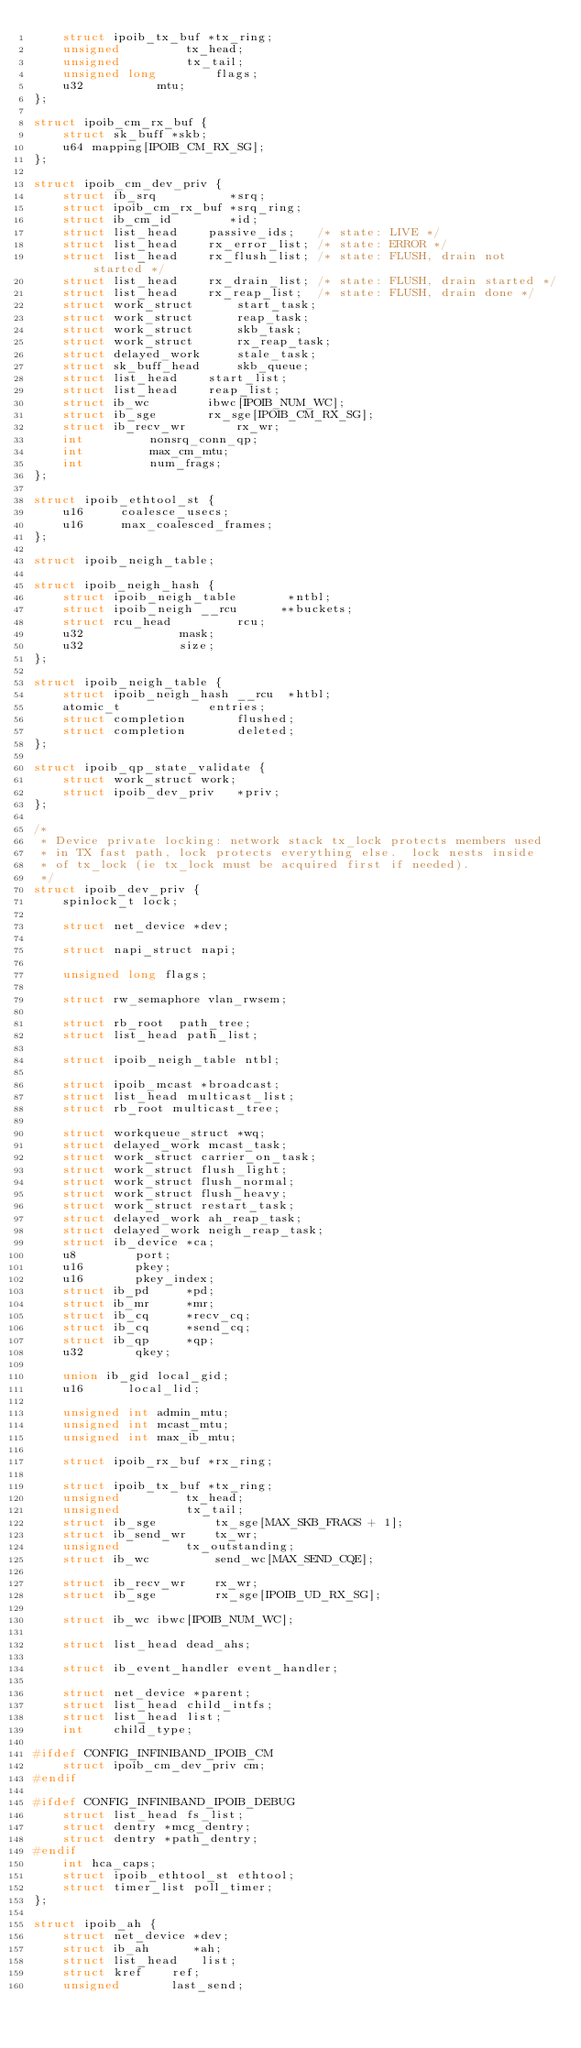<code> <loc_0><loc_0><loc_500><loc_500><_C_>	struct ipoib_tx_buf *tx_ring;
	unsigned	     tx_head;
	unsigned	     tx_tail;
	unsigned long	     flags;
	u32		     mtu;
};

struct ipoib_cm_rx_buf {
	struct sk_buff *skb;
	u64 mapping[IPOIB_CM_RX_SG];
};

struct ipoib_cm_dev_priv {
	struct ib_srq	       *srq;
	struct ipoib_cm_rx_buf *srq_ring;
	struct ib_cm_id	       *id;
	struct list_head	passive_ids;   /* state: LIVE */
	struct list_head	rx_error_list; /* state: ERROR */
	struct list_head	rx_flush_list; /* state: FLUSH, drain not started */
	struct list_head	rx_drain_list; /* state: FLUSH, drain started */
	struct list_head	rx_reap_list;  /* state: FLUSH, drain done */
	struct work_struct      start_task;
	struct work_struct      reap_task;
	struct work_struct      skb_task;
	struct work_struct      rx_reap_task;
	struct delayed_work     stale_task;
	struct sk_buff_head     skb_queue;
	struct list_head	start_list;
	struct list_head	reap_list;
	struct ib_wc		ibwc[IPOIB_NUM_WC];
	struct ib_sge		rx_sge[IPOIB_CM_RX_SG];
	struct ib_recv_wr       rx_wr;
	int			nonsrq_conn_qp;
	int			max_cm_mtu;
	int			num_frags;
};

struct ipoib_ethtool_st {
	u16     coalesce_usecs;
	u16     max_coalesced_frames;
};

struct ipoib_neigh_table;

struct ipoib_neigh_hash {
	struct ipoib_neigh_table       *ntbl;
	struct ipoib_neigh __rcu      **buckets;
	struct rcu_head			rcu;
	u32				mask;
	u32				size;
};

struct ipoib_neigh_table {
	struct ipoib_neigh_hash __rcu  *htbl;
	atomic_t			entries;
	struct completion		flushed;
	struct completion		deleted;
};

struct ipoib_qp_state_validate {
	struct work_struct work;
	struct ipoib_dev_priv   *priv;
};

/*
 * Device private locking: network stack tx_lock protects members used
 * in TX fast path, lock protects everything else.  lock nests inside
 * of tx_lock (ie tx_lock must be acquired first if needed).
 */
struct ipoib_dev_priv {
	spinlock_t lock;

	struct net_device *dev;

	struct napi_struct napi;

	unsigned long flags;

	struct rw_semaphore vlan_rwsem;

	struct rb_root  path_tree;
	struct list_head path_list;

	struct ipoib_neigh_table ntbl;

	struct ipoib_mcast *broadcast;
	struct list_head multicast_list;
	struct rb_root multicast_tree;

	struct workqueue_struct *wq;
	struct delayed_work mcast_task;
	struct work_struct carrier_on_task;
	struct work_struct flush_light;
	struct work_struct flush_normal;
	struct work_struct flush_heavy;
	struct work_struct restart_task;
	struct delayed_work ah_reap_task;
	struct delayed_work neigh_reap_task;
	struct ib_device *ca;
	u8		  port;
	u16		  pkey;
	u16		  pkey_index;
	struct ib_pd	 *pd;
	struct ib_mr	 *mr;
	struct ib_cq	 *recv_cq;
	struct ib_cq	 *send_cq;
	struct ib_qp	 *qp;
	u32		  qkey;

	union ib_gid local_gid;
	u16	     local_lid;

	unsigned int admin_mtu;
	unsigned int mcast_mtu;
	unsigned int max_ib_mtu;

	struct ipoib_rx_buf *rx_ring;

	struct ipoib_tx_buf *tx_ring;
	unsigned	     tx_head;
	unsigned	     tx_tail;
	struct ib_sge	     tx_sge[MAX_SKB_FRAGS + 1];
	struct ib_send_wr    tx_wr;
	unsigned	     tx_outstanding;
	struct ib_wc	     send_wc[MAX_SEND_CQE];

	struct ib_recv_wr    rx_wr;
	struct ib_sge	     rx_sge[IPOIB_UD_RX_SG];

	struct ib_wc ibwc[IPOIB_NUM_WC];

	struct list_head dead_ahs;

	struct ib_event_handler event_handler;

	struct net_device *parent;
	struct list_head child_intfs;
	struct list_head list;
	int    child_type;

#ifdef CONFIG_INFINIBAND_IPOIB_CM
	struct ipoib_cm_dev_priv cm;
#endif

#ifdef CONFIG_INFINIBAND_IPOIB_DEBUG
	struct list_head fs_list;
	struct dentry *mcg_dentry;
	struct dentry *path_dentry;
#endif
	int	hca_caps;
	struct ipoib_ethtool_st ethtool;
	struct timer_list poll_timer;
};

struct ipoib_ah {
	struct net_device *dev;
	struct ib_ah	  *ah;
	struct list_head   list;
	struct kref	   ref;
	unsigned	   last_send;</code> 